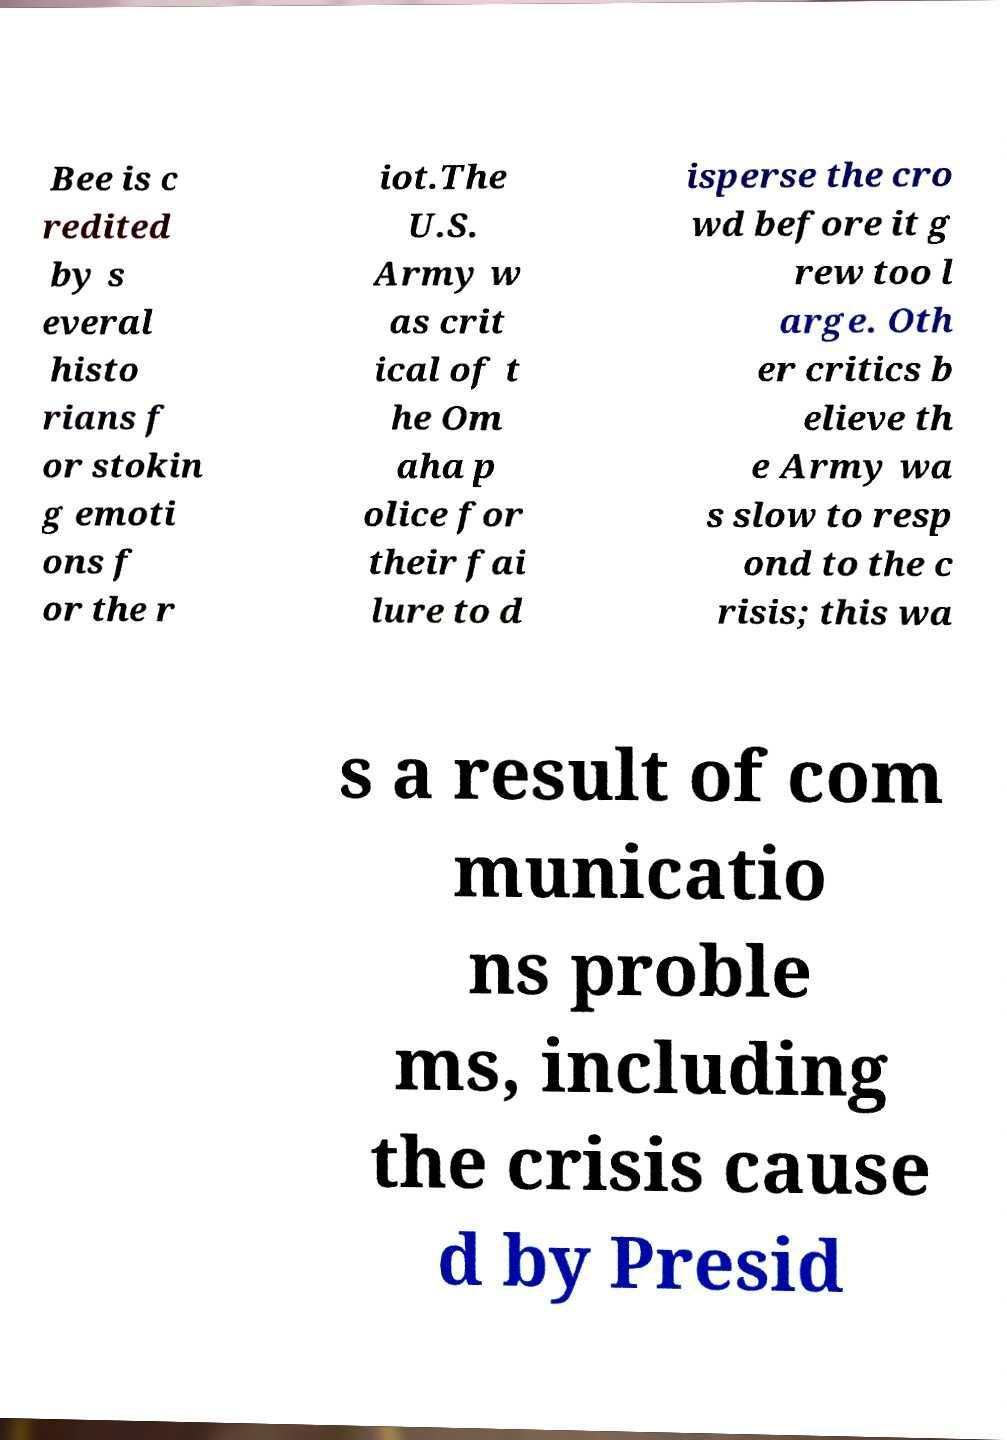There's text embedded in this image that I need extracted. Can you transcribe it verbatim? Bee is c redited by s everal histo rians f or stokin g emoti ons f or the r iot.The U.S. Army w as crit ical of t he Om aha p olice for their fai lure to d isperse the cro wd before it g rew too l arge. Oth er critics b elieve th e Army wa s slow to resp ond to the c risis; this wa s a result of com municatio ns proble ms, including the crisis cause d by Presid 